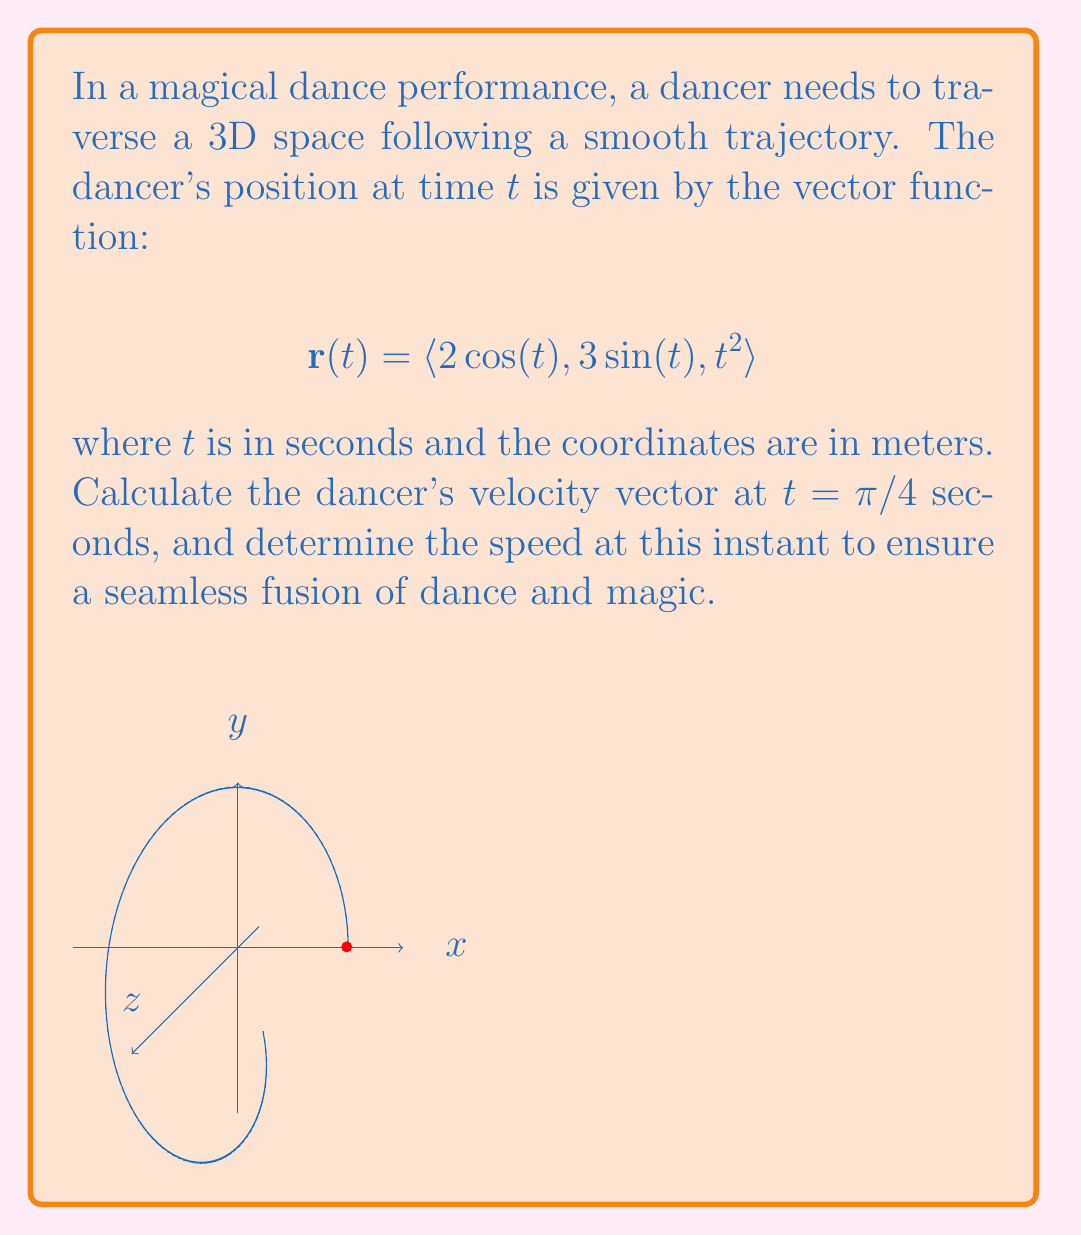Help me with this question. To solve this problem, we'll follow these steps:

1) First, we need to find the velocity vector. The velocity vector is the derivative of the position vector with respect to time:

   $$\mathbf{v}(t) = \frac{d\mathbf{r}}{dt} = \langle -2\sin(t), 3\cos(t), 2t \rangle$$

2) Now, we need to evaluate this at $t = \pi/4$:

   $$\mathbf{v}(\pi/4) = \langle -2\sin(\pi/4), 3\cos(\pi/4), 2(\pi/4) \rangle$$

3) We know that $\sin(\pi/4) = \cos(\pi/4) = \frac{\sqrt{2}}{2}$, so:

   $$\mathbf{v}(\pi/4) = \langle -\sqrt{2}, \frac{3\sqrt{2}}{2}, \frac{\pi}{2} \rangle$$

4) To find the speed, we need to calculate the magnitude of the velocity vector:

   $$\text{speed} = |\mathbf{v}(\pi/4)| = \sqrt{(-\sqrt{2})^2 + (\frac{3\sqrt{2}}{2})^2 + (\frac{\pi}{2})^2}$$

5) Simplifying under the square root:

   $$\text{speed} = \sqrt{2 + \frac{9}{2} + \frac{\pi^2}{4}}$$

6) This can be further simplified to:

   $$\text{speed} = \sqrt{\frac{13}{2} + \frac{\pi^2}{4}}$$

Thus, the velocity vector at $t = \pi/4$ is $\langle -\sqrt{2}, \frac{3\sqrt{2}}{2}, \frac{\pi}{2} \rangle$ m/s, and the speed at this instant is $\sqrt{\frac{13}{2} + \frac{\pi^2}{4}}$ m/s.
Answer: Velocity: $\langle -\sqrt{2}, \frac{3\sqrt{2}}{2}, \frac{\pi}{2} \rangle$ m/s; Speed: $\sqrt{\frac{13}{2} + \frac{\pi^2}{4}}$ m/s 